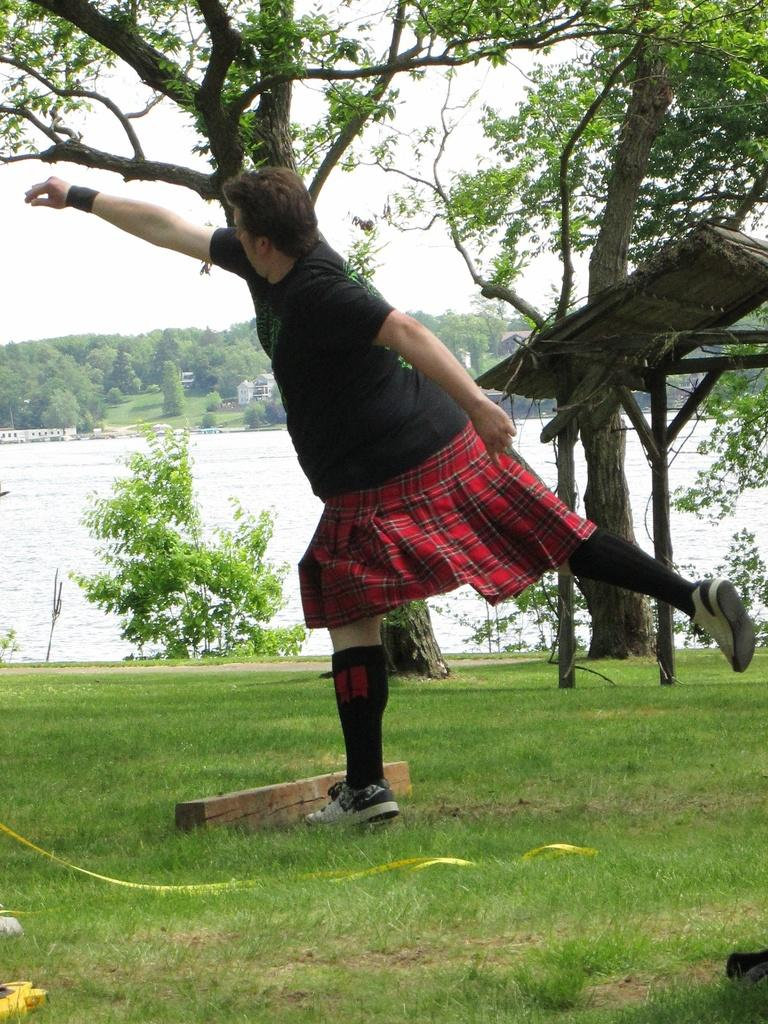Who is present in the image? There is a person in the image. What is the person wearing? The person is wearing a black t-shirt and a skirt. What type of environment is depicted in the image? There is grass, trees, and water visible in the image, suggesting a natural setting. What type of poison is the person holding in the image? There is no poison present in the image; the person is not holding any such object. What wish does the person make while standing near the water? There is no indication in the image that the person is making a wish or engaging in any such activity. 